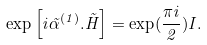Convert formula to latex. <formula><loc_0><loc_0><loc_500><loc_500>\exp \left [ i \vec { \alpha } ^ { ( 1 ) } . \vec { H } \right ] = \exp ( \frac { \pi i } { 2 } ) I .</formula> 